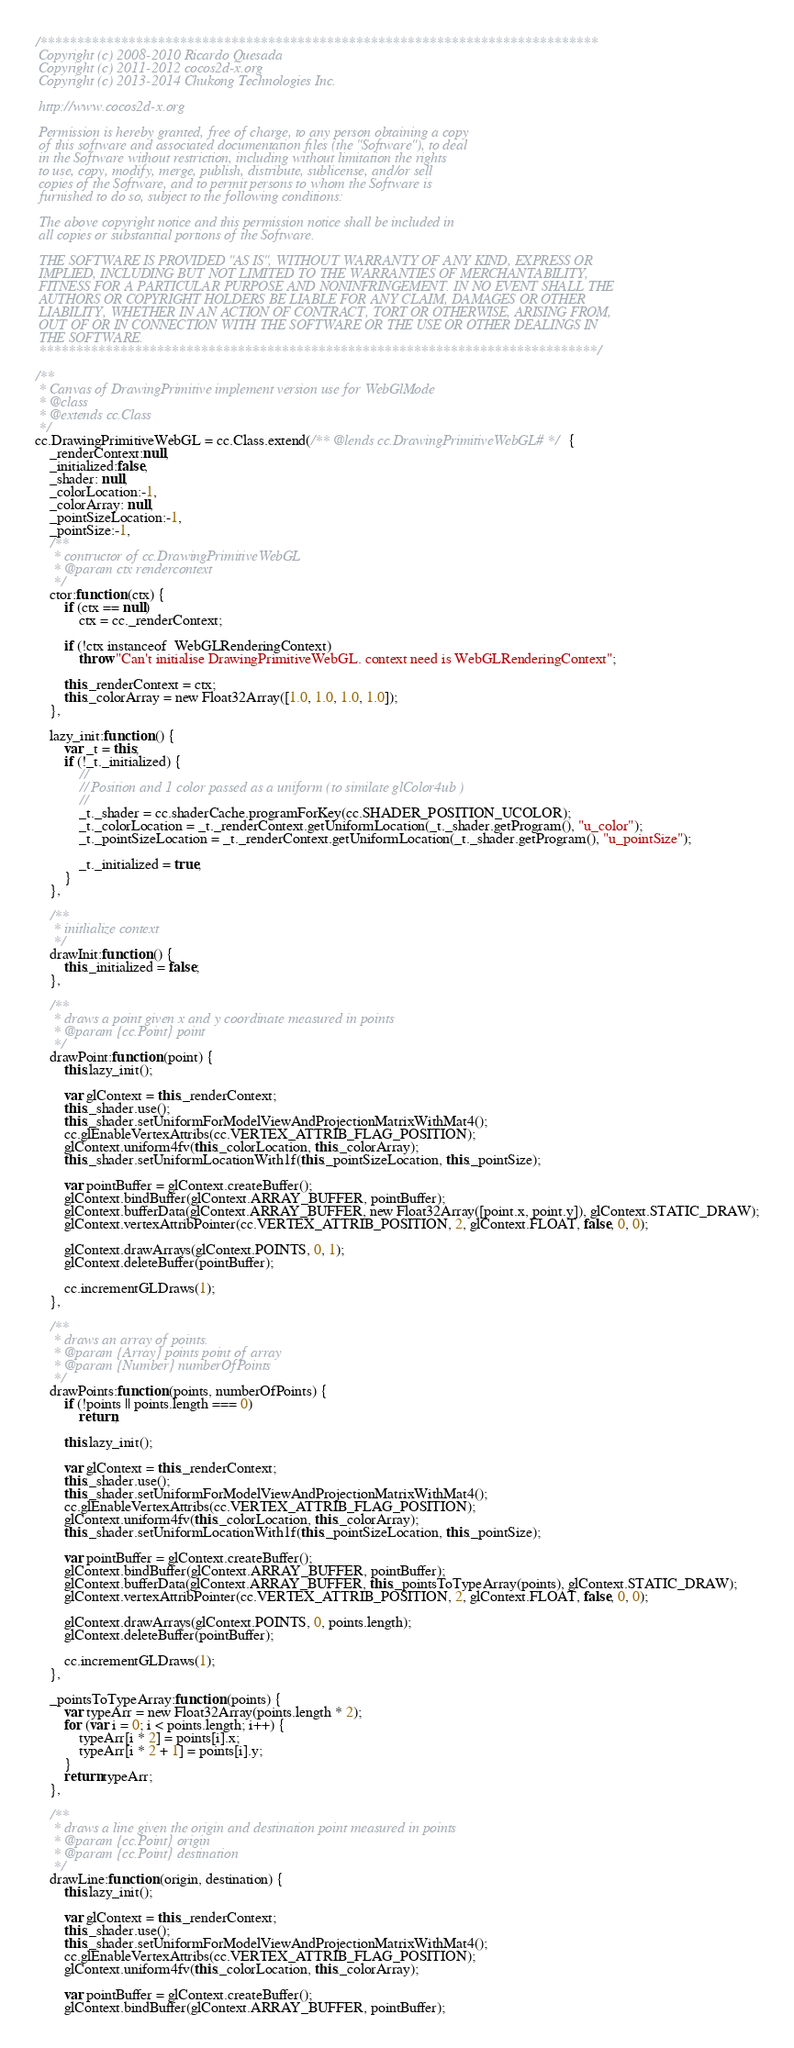<code> <loc_0><loc_0><loc_500><loc_500><_JavaScript_>/****************************************************************************
 Copyright (c) 2008-2010 Ricardo Quesada
 Copyright (c) 2011-2012 cocos2d-x.org
 Copyright (c) 2013-2014 Chukong Technologies Inc.

 http://www.cocos2d-x.org

 Permission is hereby granted, free of charge, to any person obtaining a copy
 of this software and associated documentation files (the "Software"), to deal
 in the Software without restriction, including without limitation the rights
 to use, copy, modify, merge, publish, distribute, sublicense, and/or sell
 copies of the Software, and to permit persons to whom the Software is
 furnished to do so, subject to the following conditions:

 The above copyright notice and this permission notice shall be included in
 all copies or substantial portions of the Software.

 THE SOFTWARE IS PROVIDED "AS IS", WITHOUT WARRANTY OF ANY KIND, EXPRESS OR
 IMPLIED, INCLUDING BUT NOT LIMITED TO THE WARRANTIES OF MERCHANTABILITY,
 FITNESS FOR A PARTICULAR PURPOSE AND NONINFRINGEMENT. IN NO EVENT SHALL THE
 AUTHORS OR COPYRIGHT HOLDERS BE LIABLE FOR ANY CLAIM, DAMAGES OR OTHER
 LIABILITY, WHETHER IN AN ACTION OF CONTRACT, TORT OR OTHERWISE, ARISING FROM,
 OUT OF OR IN CONNECTION WITH THE SOFTWARE OR THE USE OR OTHER DEALINGS IN
 THE SOFTWARE.
 ****************************************************************************/

/**
 * Canvas of DrawingPrimitive implement version use for WebGlMode
 * @class
 * @extends cc.Class
 */
cc.DrawingPrimitiveWebGL = cc.Class.extend(/** @lends cc.DrawingPrimitiveWebGL# */{
    _renderContext:null,
    _initialized:false,
    _shader: null,
    _colorLocation:-1,
    _colorArray: null,
    _pointSizeLocation:-1,
    _pointSize:-1,
    /**
     * contructor of cc.DrawingPrimitiveWebGL
     * @param ctx rendercontext
     */
    ctor:function (ctx) {
        if (ctx == null)
            ctx = cc._renderContext;

        if (!ctx instanceof  WebGLRenderingContext)
            throw "Can't initialise DrawingPrimitiveWebGL. context need is WebGLRenderingContext";

        this._renderContext = ctx;
        this._colorArray = new Float32Array([1.0, 1.0, 1.0, 1.0]);
    },

    lazy_init:function () {
        var _t = this;
        if (!_t._initialized) {
            //
            // Position and 1 color passed as a uniform (to similate glColor4ub )
            //
            _t._shader = cc.shaderCache.programForKey(cc.SHADER_POSITION_UCOLOR);
            _t._colorLocation = _t._renderContext.getUniformLocation(_t._shader.getProgram(), "u_color");
            _t._pointSizeLocation = _t._renderContext.getUniformLocation(_t._shader.getProgram(), "u_pointSize");

            _t._initialized = true;
        }
    },

    /**
     * initlialize context
     */
    drawInit:function () {
        this._initialized = false;
    },

    /**
     * draws a point given x and y coordinate measured in points
     * @param {cc.Point} point
     */
    drawPoint:function (point) {
        this.lazy_init();

        var glContext = this._renderContext;
        this._shader.use();
        this._shader.setUniformForModelViewAndProjectionMatrixWithMat4();
        cc.glEnableVertexAttribs(cc.VERTEX_ATTRIB_FLAG_POSITION);
        glContext.uniform4fv(this._colorLocation, this._colorArray);
        this._shader.setUniformLocationWith1f(this._pointSizeLocation, this._pointSize);

        var pointBuffer = glContext.createBuffer();
        glContext.bindBuffer(glContext.ARRAY_BUFFER, pointBuffer);
        glContext.bufferData(glContext.ARRAY_BUFFER, new Float32Array([point.x, point.y]), glContext.STATIC_DRAW);
        glContext.vertexAttribPointer(cc.VERTEX_ATTRIB_POSITION, 2, glContext.FLOAT, false, 0, 0);

        glContext.drawArrays(glContext.POINTS, 0, 1);
        glContext.deleteBuffer(pointBuffer);

        cc.incrementGLDraws(1);
    },

    /**
     * draws an array of points.
     * @param {Array} points point of array
     * @param {Number} numberOfPoints
     */
    drawPoints:function (points, numberOfPoints) {
        if (!points || points.length === 0)
            return;

        this.lazy_init();

        var glContext = this._renderContext;
        this._shader.use();
        this._shader.setUniformForModelViewAndProjectionMatrixWithMat4();
        cc.glEnableVertexAttribs(cc.VERTEX_ATTRIB_FLAG_POSITION);
        glContext.uniform4fv(this._colorLocation, this._colorArray);
        this._shader.setUniformLocationWith1f(this._pointSizeLocation, this._pointSize);

        var pointBuffer = glContext.createBuffer();
        glContext.bindBuffer(glContext.ARRAY_BUFFER, pointBuffer);
        glContext.bufferData(glContext.ARRAY_BUFFER, this._pointsToTypeArray(points), glContext.STATIC_DRAW);
        glContext.vertexAttribPointer(cc.VERTEX_ATTRIB_POSITION, 2, glContext.FLOAT, false, 0, 0);

        glContext.drawArrays(glContext.POINTS, 0, points.length);
        glContext.deleteBuffer(pointBuffer);

        cc.incrementGLDraws(1);
    },

    _pointsToTypeArray:function (points) {
        var typeArr = new Float32Array(points.length * 2);
        for (var i = 0; i < points.length; i++) {
            typeArr[i * 2] = points[i].x;
            typeArr[i * 2 + 1] = points[i].y;
        }
        return typeArr;
    },

    /**
     * draws a line given the origin and destination point measured in points
     * @param {cc.Point} origin
     * @param {cc.Point} destination
     */
    drawLine:function (origin, destination) {
        this.lazy_init();

        var glContext = this._renderContext;
        this._shader.use();
        this._shader.setUniformForModelViewAndProjectionMatrixWithMat4();
        cc.glEnableVertexAttribs(cc.VERTEX_ATTRIB_FLAG_POSITION);
        glContext.uniform4fv(this._colorLocation, this._colorArray);

        var pointBuffer = glContext.createBuffer();
        glContext.bindBuffer(glContext.ARRAY_BUFFER, pointBuffer);</code> 